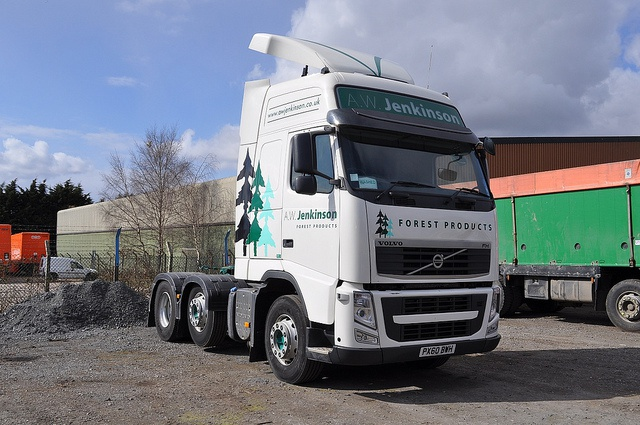Describe the objects in this image and their specific colors. I can see truck in darkgray, black, lightgray, and gray tones, truck in darkgray, green, black, and gray tones, truck in darkgray, brown, maroon, black, and red tones, truck in darkgray, gray, and black tones, and truck in darkgray, brown, maroon, and black tones in this image. 